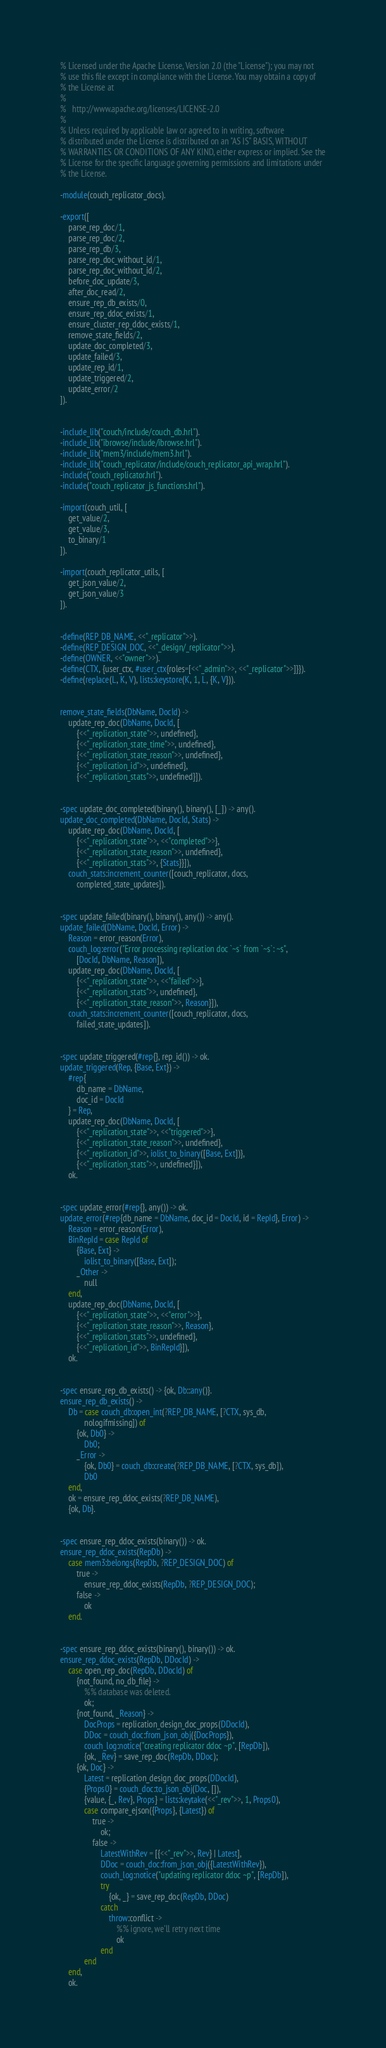Convert code to text. <code><loc_0><loc_0><loc_500><loc_500><_Erlang_>% Licensed under the Apache License, Version 2.0 (the "License"); you may not
% use this file except in compliance with the License. You may obtain a copy of
% the License at
%
%   http://www.apache.org/licenses/LICENSE-2.0
%
% Unless required by applicable law or agreed to in writing, software
% distributed under the License is distributed on an "AS IS" BASIS, WITHOUT
% WARRANTIES OR CONDITIONS OF ANY KIND, either express or implied. See the
% License for the specific language governing permissions and limitations under
% the License.

-module(couch_replicator_docs).

-export([
    parse_rep_doc/1,
    parse_rep_doc/2,
    parse_rep_db/3,
    parse_rep_doc_without_id/1,
    parse_rep_doc_without_id/2,
    before_doc_update/3,
    after_doc_read/2,
    ensure_rep_db_exists/0,
    ensure_rep_ddoc_exists/1,
    ensure_cluster_rep_ddoc_exists/1,
    remove_state_fields/2,
    update_doc_completed/3,
    update_failed/3,
    update_rep_id/1,
    update_triggered/2,
    update_error/2
]).


-include_lib("couch/include/couch_db.hrl").
-include_lib("ibrowse/include/ibrowse.hrl").
-include_lib("mem3/include/mem3.hrl").
-include_lib("couch_replicator/include/couch_replicator_api_wrap.hrl").
-include("couch_replicator.hrl").
-include("couch_replicator_js_functions.hrl").

-import(couch_util, [
    get_value/2,
    get_value/3,
    to_binary/1
]).

-import(couch_replicator_utils, [
    get_json_value/2,
    get_json_value/3
]).


-define(REP_DB_NAME, <<"_replicator">>).
-define(REP_DESIGN_DOC, <<"_design/_replicator">>).
-define(OWNER, <<"owner">>).
-define(CTX, {user_ctx, #user_ctx{roles=[<<"_admin">>, <<"_replicator">>]}}).
-define(replace(L, K, V), lists:keystore(K, 1, L, {K, V})).


remove_state_fields(DbName, DocId) ->
    update_rep_doc(DbName, DocId, [
        {<<"_replication_state">>, undefined},
        {<<"_replication_state_time">>, undefined},
        {<<"_replication_state_reason">>, undefined},
        {<<"_replication_id">>, undefined},
        {<<"_replication_stats">>, undefined}]).


-spec update_doc_completed(binary(), binary(), [_]) -> any().
update_doc_completed(DbName, DocId, Stats) ->
    update_rep_doc(DbName, DocId, [
        {<<"_replication_state">>, <<"completed">>},
        {<<"_replication_state_reason">>, undefined},
        {<<"_replication_stats">>, {Stats}}]),
    couch_stats:increment_counter([couch_replicator, docs,
        completed_state_updates]).


-spec update_failed(binary(), binary(), any()) -> any().
update_failed(DbName, DocId, Error) ->
    Reason = error_reason(Error),
    couch_log:error("Error processing replication doc `~s` from `~s`: ~s",
        [DocId, DbName, Reason]),
    update_rep_doc(DbName, DocId, [
        {<<"_replication_state">>, <<"failed">>},
        {<<"_replication_stats">>, undefined},
        {<<"_replication_state_reason">>, Reason}]),
    couch_stats:increment_counter([couch_replicator, docs,
        failed_state_updates]).


-spec update_triggered(#rep{}, rep_id()) -> ok.
update_triggered(Rep, {Base, Ext}) ->
    #rep{
        db_name = DbName,
        doc_id = DocId
    } = Rep,
    update_rep_doc(DbName, DocId, [
        {<<"_replication_state">>, <<"triggered">>},
        {<<"_replication_state_reason">>, undefined},
        {<<"_replication_id">>, iolist_to_binary([Base, Ext])},
        {<<"_replication_stats">>, undefined}]),
    ok.


-spec update_error(#rep{}, any()) -> ok.
update_error(#rep{db_name = DbName, doc_id = DocId, id = RepId}, Error) ->
    Reason = error_reason(Error),
    BinRepId = case RepId of
        {Base, Ext} ->
            iolist_to_binary([Base, Ext]);
        _Other ->
            null
    end,
    update_rep_doc(DbName, DocId, [
        {<<"_replication_state">>, <<"error">>},
        {<<"_replication_state_reason">>, Reason},
        {<<"_replication_stats">>, undefined},
        {<<"_replication_id">>, BinRepId}]),
    ok.


-spec ensure_rep_db_exists() -> {ok, Db::any()}.
ensure_rep_db_exists() ->
    Db = case couch_db:open_int(?REP_DB_NAME, [?CTX, sys_db,
            nologifmissing]) of
        {ok, Db0} ->
            Db0;
        _Error ->
            {ok, Db0} = couch_db:create(?REP_DB_NAME, [?CTX, sys_db]),
            Db0
    end,
    ok = ensure_rep_ddoc_exists(?REP_DB_NAME),
    {ok, Db}.


-spec ensure_rep_ddoc_exists(binary()) -> ok.
ensure_rep_ddoc_exists(RepDb) ->
    case mem3:belongs(RepDb, ?REP_DESIGN_DOC) of
        true ->
            ensure_rep_ddoc_exists(RepDb, ?REP_DESIGN_DOC);
        false ->
            ok
    end.


-spec ensure_rep_ddoc_exists(binary(), binary()) -> ok.
ensure_rep_ddoc_exists(RepDb, DDocId) ->
    case open_rep_doc(RepDb, DDocId) of
        {not_found, no_db_file} ->
            %% database was deleted.
            ok;
        {not_found, _Reason} ->
            DocProps = replication_design_doc_props(DDocId),
            DDoc = couch_doc:from_json_obj({DocProps}),
            couch_log:notice("creating replicator ddoc ~p", [RepDb]),
            {ok, _Rev} = save_rep_doc(RepDb, DDoc);
        {ok, Doc} ->
            Latest = replication_design_doc_props(DDocId),
            {Props0} = couch_doc:to_json_obj(Doc, []),
            {value, {_, Rev}, Props} = lists:keytake(<<"_rev">>, 1, Props0),
            case compare_ejson({Props}, {Latest}) of
                true ->
                    ok;
                false ->
                    LatestWithRev = [{<<"_rev">>, Rev} | Latest],
                    DDoc = couch_doc:from_json_obj({LatestWithRev}),
                    couch_log:notice("updating replicator ddoc ~p", [RepDb]),
                    try
                        {ok, _} = save_rep_doc(RepDb, DDoc)
                    catch
                        throw:conflict ->
                            %% ignore, we'll retry next time
                            ok
                    end
            end
    end,
    ok.

</code> 